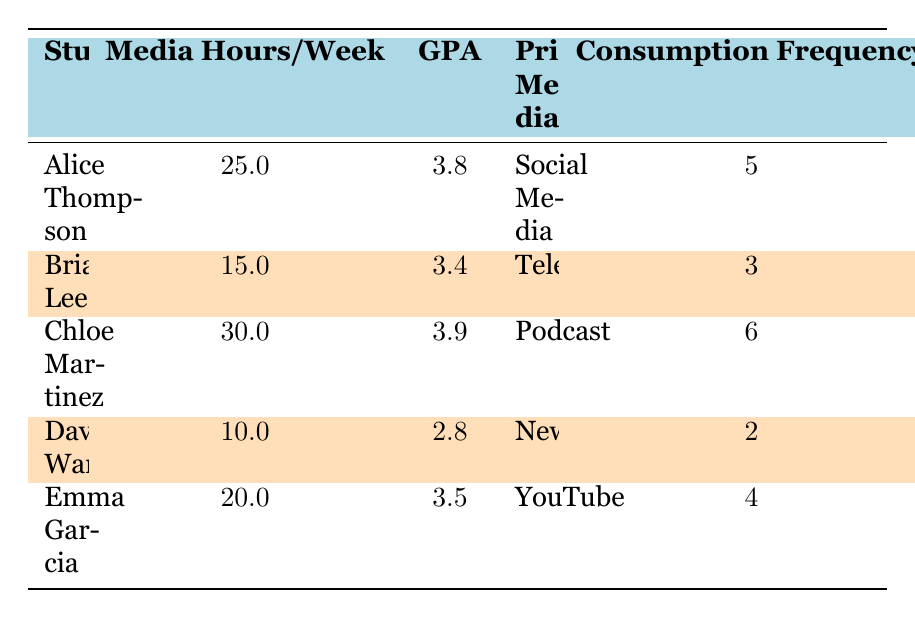What is the GPA of Alice Thompson? The table directly lists the GPA for each student. Alice Thompson's GPA is contained in the same row where her name is found.
Answer: 3.8 What media does David Wang primarily use? The table provides the primary media used by each student in the designated column. For David Wang, the primary media listed is Newspaper.
Answer: Newspaper Which student has the highest frequency of media consumption? To find this, I compare the consumption frequency values in the table. Chloe Martinez has a frequency of 6, which is higher than all others.
Answer: Chloe Martinez What is the average GPA of the journalism students listed? To calculate the average GPA, I sum the GPAs of all students: (3.8 + 3.4 + 3.9 + 2.8 + 3.5) = 17.4. Then, I divide by the number of students (5). This results in an average GPA of 17.4 / 5 = 3.48.
Answer: 3.48 Is Emma Garcia engaged in high journalistic activities? I check the engagement column for Emma Garcia. It indicates "Medium," not "High." Thus, the statement is false.
Answer: No Which student's media consumption hours are below the average? First, I find the average media consumption hours: (25 + 15 + 30 + 10 + 20) / 5 = 20. Then, I check each student's hours against this average. David Wang has the lowest hours at 10, which is below the average.
Answer: David Wang How many students use Social Media as their primary media? The table lists students along with their primary media. I count the occurrences of "Social Media" under the primary media column. Only Alice Thompson uses Social Media as her primary medium.
Answer: 1 What is the total number of media hours consumed by all students collectively? I sum the media hours for each student: 25 + 15 + 30 + 10 + 20 = 110. Thus, the total number of media hours consumed is 110.
Answer: 110 Is there a correlation between high engagement in journalistic activities and higher GPAs based on the students listed? I evaluate the engagement levels and the corresponding GPAs. Both Alice Thompson and Chloe Martinez have high engagement and higher GPAs (3.8 and 3.9), indicating a trend. However, David Wang is low in both scales. Therefore, there might be a correlation but not conclusively proven by this small sample.
Answer: It appears so, but not conclusively 